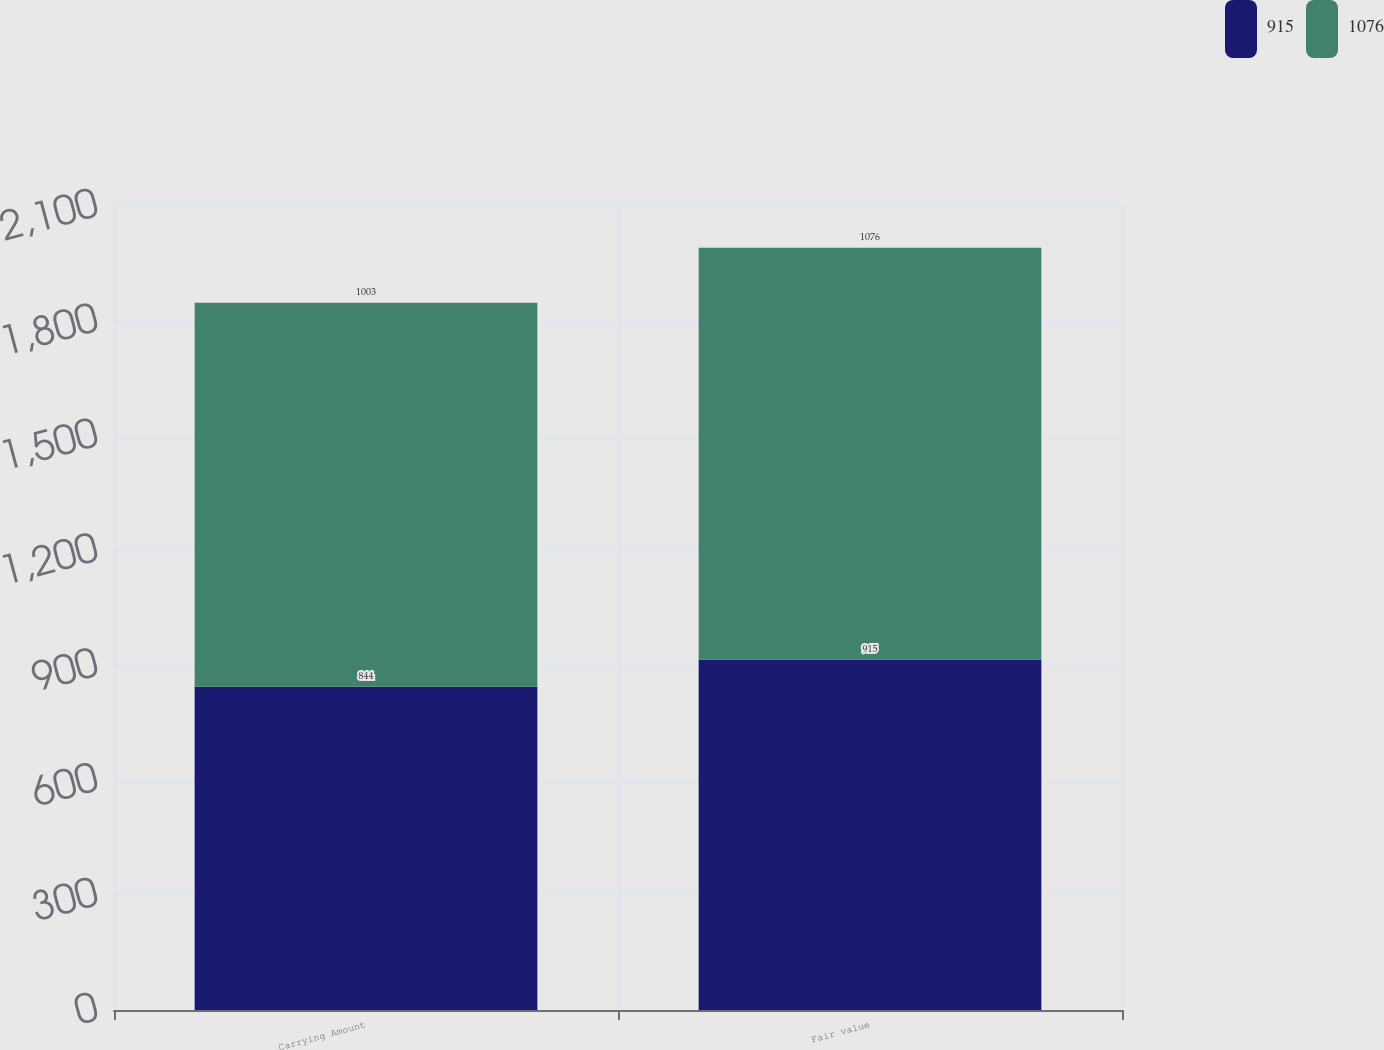<chart> <loc_0><loc_0><loc_500><loc_500><stacked_bar_chart><ecel><fcel>Carrying Amount<fcel>Fair value<nl><fcel>915<fcel>844<fcel>915<nl><fcel>1076<fcel>1003<fcel>1076<nl></chart> 